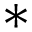<formula> <loc_0><loc_0><loc_500><loc_500>^ { * }</formula> 